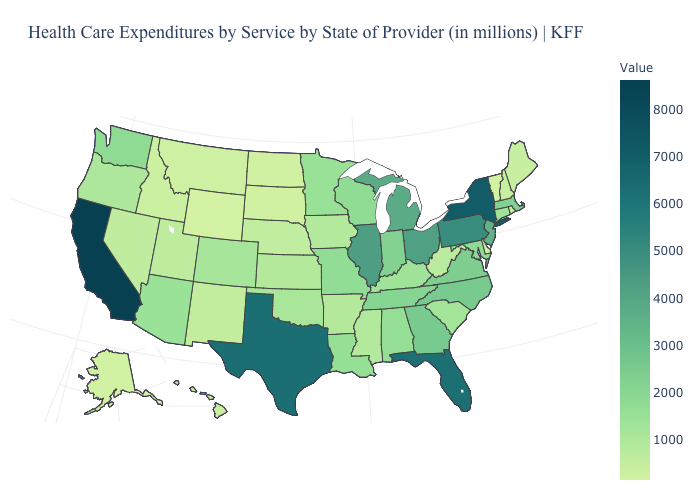Which states hav the highest value in the MidWest?
Be succinct. Illinois. Among the states that border California , does Nevada have the lowest value?
Give a very brief answer. Yes. 